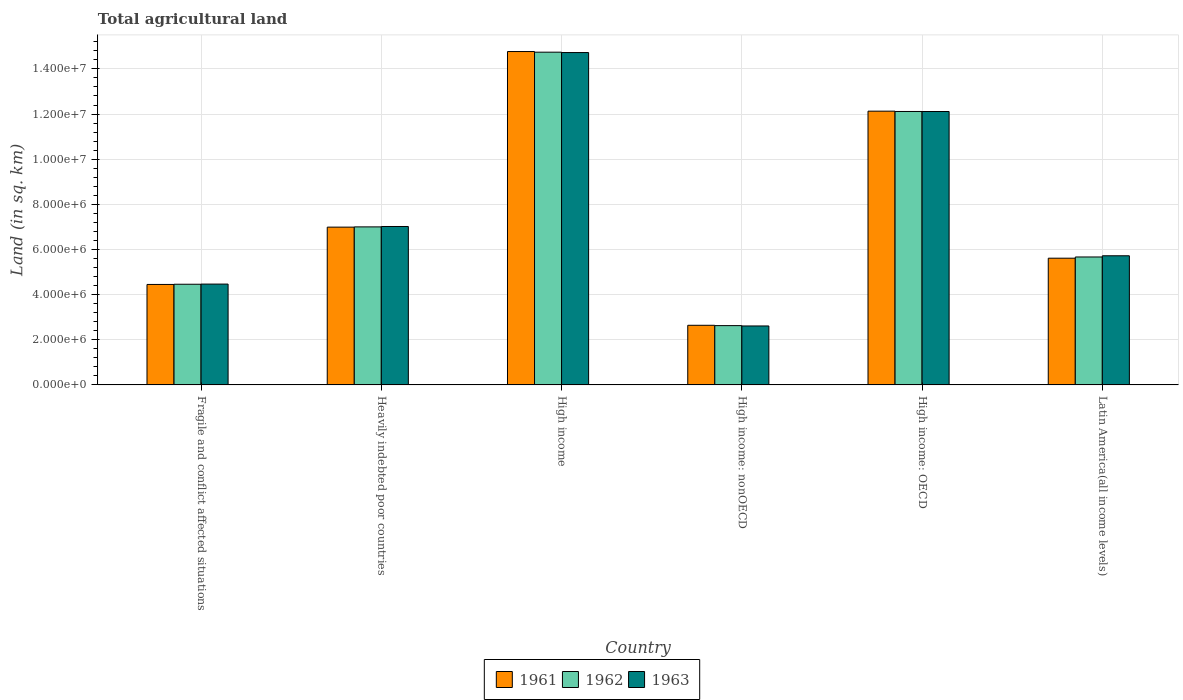How many different coloured bars are there?
Give a very brief answer. 3. Are the number of bars on each tick of the X-axis equal?
Your answer should be compact. Yes. How many bars are there on the 1st tick from the right?
Provide a succinct answer. 3. What is the label of the 6th group of bars from the left?
Provide a short and direct response. Latin America(all income levels). What is the total agricultural land in 1961 in High income?
Make the answer very short. 1.48e+07. Across all countries, what is the maximum total agricultural land in 1962?
Provide a short and direct response. 1.47e+07. Across all countries, what is the minimum total agricultural land in 1962?
Give a very brief answer. 2.63e+06. In which country was the total agricultural land in 1963 minimum?
Offer a very short reply. High income: nonOECD. What is the total total agricultural land in 1962 in the graph?
Your response must be concise. 4.66e+07. What is the difference between the total agricultural land in 1962 in Fragile and conflict affected situations and that in High income: OECD?
Offer a terse response. -7.65e+06. What is the difference between the total agricultural land in 1963 in Latin America(all income levels) and the total agricultural land in 1961 in High income: nonOECD?
Offer a terse response. 3.08e+06. What is the average total agricultural land in 1962 per country?
Offer a very short reply. 7.77e+06. What is the difference between the total agricultural land of/in 1961 and total agricultural land of/in 1963 in High income?
Give a very brief answer. 4.49e+04. In how many countries, is the total agricultural land in 1961 greater than 7200000 sq.km?
Provide a short and direct response. 2. What is the ratio of the total agricultural land in 1963 in Fragile and conflict affected situations to that in High income: nonOECD?
Your answer should be very brief. 1.71. Is the difference between the total agricultural land in 1961 in High income and Latin America(all income levels) greater than the difference between the total agricultural land in 1963 in High income and Latin America(all income levels)?
Provide a short and direct response. Yes. What is the difference between the highest and the second highest total agricultural land in 1963?
Offer a very short reply. -7.71e+06. What is the difference between the highest and the lowest total agricultural land in 1962?
Provide a succinct answer. 1.21e+07. In how many countries, is the total agricultural land in 1963 greater than the average total agricultural land in 1963 taken over all countries?
Provide a succinct answer. 2. What does the 2nd bar from the left in High income: nonOECD represents?
Your answer should be compact. 1962. What does the 3rd bar from the right in High income represents?
Keep it short and to the point. 1961. Is it the case that in every country, the sum of the total agricultural land in 1962 and total agricultural land in 1963 is greater than the total agricultural land in 1961?
Ensure brevity in your answer.  Yes. How many bars are there?
Offer a terse response. 18. Are the values on the major ticks of Y-axis written in scientific E-notation?
Offer a terse response. Yes. Does the graph contain any zero values?
Ensure brevity in your answer.  No. Does the graph contain grids?
Make the answer very short. Yes. What is the title of the graph?
Provide a succinct answer. Total agricultural land. Does "1990" appear as one of the legend labels in the graph?
Provide a short and direct response. No. What is the label or title of the Y-axis?
Offer a very short reply. Land (in sq. km). What is the Land (in sq. km) of 1961 in Fragile and conflict affected situations?
Your answer should be compact. 4.45e+06. What is the Land (in sq. km) of 1962 in Fragile and conflict affected situations?
Your answer should be compact. 4.46e+06. What is the Land (in sq. km) in 1963 in Fragile and conflict affected situations?
Keep it short and to the point. 4.47e+06. What is the Land (in sq. km) in 1961 in Heavily indebted poor countries?
Give a very brief answer. 6.99e+06. What is the Land (in sq. km) in 1962 in Heavily indebted poor countries?
Your response must be concise. 7.00e+06. What is the Land (in sq. km) in 1963 in Heavily indebted poor countries?
Offer a terse response. 7.02e+06. What is the Land (in sq. km) of 1961 in High income?
Your answer should be very brief. 1.48e+07. What is the Land (in sq. km) of 1962 in High income?
Your answer should be compact. 1.47e+07. What is the Land (in sq. km) in 1963 in High income?
Your response must be concise. 1.47e+07. What is the Land (in sq. km) of 1961 in High income: nonOECD?
Keep it short and to the point. 2.64e+06. What is the Land (in sq. km) of 1962 in High income: nonOECD?
Offer a very short reply. 2.63e+06. What is the Land (in sq. km) of 1963 in High income: nonOECD?
Provide a short and direct response. 2.61e+06. What is the Land (in sq. km) in 1961 in High income: OECD?
Keep it short and to the point. 1.21e+07. What is the Land (in sq. km) of 1962 in High income: OECD?
Offer a terse response. 1.21e+07. What is the Land (in sq. km) in 1963 in High income: OECD?
Keep it short and to the point. 1.21e+07. What is the Land (in sq. km) of 1961 in Latin America(all income levels)?
Keep it short and to the point. 5.61e+06. What is the Land (in sq. km) in 1962 in Latin America(all income levels)?
Give a very brief answer. 5.67e+06. What is the Land (in sq. km) of 1963 in Latin America(all income levels)?
Provide a short and direct response. 5.72e+06. Across all countries, what is the maximum Land (in sq. km) of 1961?
Provide a short and direct response. 1.48e+07. Across all countries, what is the maximum Land (in sq. km) of 1962?
Your response must be concise. 1.47e+07. Across all countries, what is the maximum Land (in sq. km) of 1963?
Your response must be concise. 1.47e+07. Across all countries, what is the minimum Land (in sq. km) of 1961?
Offer a terse response. 2.64e+06. Across all countries, what is the minimum Land (in sq. km) in 1962?
Offer a very short reply. 2.63e+06. Across all countries, what is the minimum Land (in sq. km) in 1963?
Offer a terse response. 2.61e+06. What is the total Land (in sq. km) in 1961 in the graph?
Offer a terse response. 4.66e+07. What is the total Land (in sq. km) of 1962 in the graph?
Ensure brevity in your answer.  4.66e+07. What is the total Land (in sq. km) of 1963 in the graph?
Keep it short and to the point. 4.67e+07. What is the difference between the Land (in sq. km) in 1961 in Fragile and conflict affected situations and that in Heavily indebted poor countries?
Provide a short and direct response. -2.54e+06. What is the difference between the Land (in sq. km) in 1962 in Fragile and conflict affected situations and that in Heavily indebted poor countries?
Provide a succinct answer. -2.54e+06. What is the difference between the Land (in sq. km) in 1963 in Fragile and conflict affected situations and that in Heavily indebted poor countries?
Provide a short and direct response. -2.55e+06. What is the difference between the Land (in sq. km) of 1961 in Fragile and conflict affected situations and that in High income?
Ensure brevity in your answer.  -1.03e+07. What is the difference between the Land (in sq. km) in 1962 in Fragile and conflict affected situations and that in High income?
Ensure brevity in your answer.  -1.03e+07. What is the difference between the Land (in sq. km) of 1963 in Fragile and conflict affected situations and that in High income?
Your answer should be compact. -1.03e+07. What is the difference between the Land (in sq. km) in 1961 in Fragile and conflict affected situations and that in High income: nonOECD?
Your response must be concise. 1.81e+06. What is the difference between the Land (in sq. km) in 1962 in Fragile and conflict affected situations and that in High income: nonOECD?
Your response must be concise. 1.83e+06. What is the difference between the Land (in sq. km) in 1963 in Fragile and conflict affected situations and that in High income: nonOECD?
Provide a succinct answer. 1.86e+06. What is the difference between the Land (in sq. km) of 1961 in Fragile and conflict affected situations and that in High income: OECD?
Make the answer very short. -7.68e+06. What is the difference between the Land (in sq. km) in 1962 in Fragile and conflict affected situations and that in High income: OECD?
Give a very brief answer. -7.65e+06. What is the difference between the Land (in sq. km) of 1963 in Fragile and conflict affected situations and that in High income: OECD?
Provide a succinct answer. -7.65e+06. What is the difference between the Land (in sq. km) of 1961 in Fragile and conflict affected situations and that in Latin America(all income levels)?
Provide a short and direct response. -1.16e+06. What is the difference between the Land (in sq. km) of 1962 in Fragile and conflict affected situations and that in Latin America(all income levels)?
Provide a succinct answer. -1.21e+06. What is the difference between the Land (in sq. km) in 1963 in Fragile and conflict affected situations and that in Latin America(all income levels)?
Ensure brevity in your answer.  -1.25e+06. What is the difference between the Land (in sq. km) in 1961 in Heavily indebted poor countries and that in High income?
Offer a terse response. -7.78e+06. What is the difference between the Land (in sq. km) of 1962 in Heavily indebted poor countries and that in High income?
Your answer should be compact. -7.74e+06. What is the difference between the Land (in sq. km) of 1963 in Heavily indebted poor countries and that in High income?
Provide a short and direct response. -7.71e+06. What is the difference between the Land (in sq. km) of 1961 in Heavily indebted poor countries and that in High income: nonOECD?
Offer a very short reply. 4.35e+06. What is the difference between the Land (in sq. km) of 1962 in Heavily indebted poor countries and that in High income: nonOECD?
Ensure brevity in your answer.  4.37e+06. What is the difference between the Land (in sq. km) in 1963 in Heavily indebted poor countries and that in High income: nonOECD?
Make the answer very short. 4.41e+06. What is the difference between the Land (in sq. km) of 1961 in Heavily indebted poor countries and that in High income: OECD?
Provide a succinct answer. -5.14e+06. What is the difference between the Land (in sq. km) in 1962 in Heavily indebted poor countries and that in High income: OECD?
Make the answer very short. -5.11e+06. What is the difference between the Land (in sq. km) in 1963 in Heavily indebted poor countries and that in High income: OECD?
Offer a very short reply. -5.09e+06. What is the difference between the Land (in sq. km) of 1961 in Heavily indebted poor countries and that in Latin America(all income levels)?
Make the answer very short. 1.38e+06. What is the difference between the Land (in sq. km) in 1962 in Heavily indebted poor countries and that in Latin America(all income levels)?
Make the answer very short. 1.33e+06. What is the difference between the Land (in sq. km) in 1963 in Heavily indebted poor countries and that in Latin America(all income levels)?
Offer a very short reply. 1.30e+06. What is the difference between the Land (in sq. km) of 1961 in High income and that in High income: nonOECD?
Keep it short and to the point. 1.21e+07. What is the difference between the Land (in sq. km) of 1962 in High income and that in High income: nonOECD?
Offer a terse response. 1.21e+07. What is the difference between the Land (in sq. km) in 1963 in High income and that in High income: nonOECD?
Offer a terse response. 1.21e+07. What is the difference between the Land (in sq. km) of 1961 in High income and that in High income: OECD?
Keep it short and to the point. 2.64e+06. What is the difference between the Land (in sq. km) in 1962 in High income and that in High income: OECD?
Your response must be concise. 2.63e+06. What is the difference between the Land (in sq. km) of 1963 in High income and that in High income: OECD?
Make the answer very short. 2.61e+06. What is the difference between the Land (in sq. km) in 1961 in High income and that in Latin America(all income levels)?
Your answer should be compact. 9.15e+06. What is the difference between the Land (in sq. km) of 1962 in High income and that in Latin America(all income levels)?
Make the answer very short. 9.07e+06. What is the difference between the Land (in sq. km) of 1963 in High income and that in Latin America(all income levels)?
Keep it short and to the point. 9.00e+06. What is the difference between the Land (in sq. km) of 1961 in High income: nonOECD and that in High income: OECD?
Provide a succinct answer. -9.49e+06. What is the difference between the Land (in sq. km) in 1962 in High income: nonOECD and that in High income: OECD?
Offer a very short reply. -9.49e+06. What is the difference between the Land (in sq. km) in 1963 in High income: nonOECD and that in High income: OECD?
Give a very brief answer. -9.50e+06. What is the difference between the Land (in sq. km) of 1961 in High income: nonOECD and that in Latin America(all income levels)?
Make the answer very short. -2.97e+06. What is the difference between the Land (in sq. km) of 1962 in High income: nonOECD and that in Latin America(all income levels)?
Give a very brief answer. -3.04e+06. What is the difference between the Land (in sq. km) in 1963 in High income: nonOECD and that in Latin America(all income levels)?
Keep it short and to the point. -3.11e+06. What is the difference between the Land (in sq. km) in 1961 in High income: OECD and that in Latin America(all income levels)?
Give a very brief answer. 6.51e+06. What is the difference between the Land (in sq. km) of 1962 in High income: OECD and that in Latin America(all income levels)?
Ensure brevity in your answer.  6.44e+06. What is the difference between the Land (in sq. km) in 1963 in High income: OECD and that in Latin America(all income levels)?
Make the answer very short. 6.39e+06. What is the difference between the Land (in sq. km) of 1961 in Fragile and conflict affected situations and the Land (in sq. km) of 1962 in Heavily indebted poor countries?
Give a very brief answer. -2.55e+06. What is the difference between the Land (in sq. km) in 1961 in Fragile and conflict affected situations and the Land (in sq. km) in 1963 in Heavily indebted poor countries?
Your answer should be compact. -2.57e+06. What is the difference between the Land (in sq. km) in 1962 in Fragile and conflict affected situations and the Land (in sq. km) in 1963 in Heavily indebted poor countries?
Your answer should be very brief. -2.56e+06. What is the difference between the Land (in sq. km) in 1961 in Fragile and conflict affected situations and the Land (in sq. km) in 1962 in High income?
Your answer should be very brief. -1.03e+07. What is the difference between the Land (in sq. km) of 1961 in Fragile and conflict affected situations and the Land (in sq. km) of 1963 in High income?
Your answer should be very brief. -1.03e+07. What is the difference between the Land (in sq. km) in 1962 in Fragile and conflict affected situations and the Land (in sq. km) in 1963 in High income?
Your answer should be compact. -1.03e+07. What is the difference between the Land (in sq. km) of 1961 in Fragile and conflict affected situations and the Land (in sq. km) of 1962 in High income: nonOECD?
Give a very brief answer. 1.82e+06. What is the difference between the Land (in sq. km) of 1961 in Fragile and conflict affected situations and the Land (in sq. km) of 1963 in High income: nonOECD?
Your answer should be very brief. 1.84e+06. What is the difference between the Land (in sq. km) in 1962 in Fragile and conflict affected situations and the Land (in sq. km) in 1963 in High income: nonOECD?
Give a very brief answer. 1.85e+06. What is the difference between the Land (in sq. km) of 1961 in Fragile and conflict affected situations and the Land (in sq. km) of 1962 in High income: OECD?
Your response must be concise. -7.66e+06. What is the difference between the Land (in sq. km) in 1961 in Fragile and conflict affected situations and the Land (in sq. km) in 1963 in High income: OECD?
Give a very brief answer. -7.66e+06. What is the difference between the Land (in sq. km) in 1962 in Fragile and conflict affected situations and the Land (in sq. km) in 1963 in High income: OECD?
Make the answer very short. -7.65e+06. What is the difference between the Land (in sq. km) in 1961 in Fragile and conflict affected situations and the Land (in sq. km) in 1962 in Latin America(all income levels)?
Provide a short and direct response. -1.22e+06. What is the difference between the Land (in sq. km) in 1961 in Fragile and conflict affected situations and the Land (in sq. km) in 1963 in Latin America(all income levels)?
Make the answer very short. -1.27e+06. What is the difference between the Land (in sq. km) in 1962 in Fragile and conflict affected situations and the Land (in sq. km) in 1963 in Latin America(all income levels)?
Give a very brief answer. -1.26e+06. What is the difference between the Land (in sq. km) of 1961 in Heavily indebted poor countries and the Land (in sq. km) of 1962 in High income?
Ensure brevity in your answer.  -7.75e+06. What is the difference between the Land (in sq. km) in 1961 in Heavily indebted poor countries and the Land (in sq. km) in 1963 in High income?
Offer a very short reply. -7.73e+06. What is the difference between the Land (in sq. km) of 1962 in Heavily indebted poor countries and the Land (in sq. km) of 1963 in High income?
Make the answer very short. -7.72e+06. What is the difference between the Land (in sq. km) in 1961 in Heavily indebted poor countries and the Land (in sq. km) in 1962 in High income: nonOECD?
Give a very brief answer. 4.36e+06. What is the difference between the Land (in sq. km) in 1961 in Heavily indebted poor countries and the Land (in sq. km) in 1963 in High income: nonOECD?
Your answer should be very brief. 4.38e+06. What is the difference between the Land (in sq. km) in 1962 in Heavily indebted poor countries and the Land (in sq. km) in 1963 in High income: nonOECD?
Ensure brevity in your answer.  4.39e+06. What is the difference between the Land (in sq. km) of 1961 in Heavily indebted poor countries and the Land (in sq. km) of 1962 in High income: OECD?
Give a very brief answer. -5.12e+06. What is the difference between the Land (in sq. km) in 1961 in Heavily indebted poor countries and the Land (in sq. km) in 1963 in High income: OECD?
Provide a short and direct response. -5.12e+06. What is the difference between the Land (in sq. km) of 1962 in Heavily indebted poor countries and the Land (in sq. km) of 1963 in High income: OECD?
Offer a terse response. -5.11e+06. What is the difference between the Land (in sq. km) of 1961 in Heavily indebted poor countries and the Land (in sq. km) of 1962 in Latin America(all income levels)?
Your response must be concise. 1.32e+06. What is the difference between the Land (in sq. km) in 1961 in Heavily indebted poor countries and the Land (in sq. km) in 1963 in Latin America(all income levels)?
Your response must be concise. 1.27e+06. What is the difference between the Land (in sq. km) in 1962 in Heavily indebted poor countries and the Land (in sq. km) in 1963 in Latin America(all income levels)?
Offer a very short reply. 1.28e+06. What is the difference between the Land (in sq. km) of 1961 in High income and the Land (in sq. km) of 1962 in High income: nonOECD?
Offer a terse response. 1.21e+07. What is the difference between the Land (in sq. km) in 1961 in High income and the Land (in sq. km) in 1963 in High income: nonOECD?
Your response must be concise. 1.22e+07. What is the difference between the Land (in sq. km) of 1962 in High income and the Land (in sq. km) of 1963 in High income: nonOECD?
Ensure brevity in your answer.  1.21e+07. What is the difference between the Land (in sq. km) in 1961 in High income and the Land (in sq. km) in 1962 in High income: OECD?
Make the answer very short. 2.66e+06. What is the difference between the Land (in sq. km) in 1961 in High income and the Land (in sq. km) in 1963 in High income: OECD?
Give a very brief answer. 2.66e+06. What is the difference between the Land (in sq. km) of 1962 in High income and the Land (in sq. km) of 1963 in High income: OECD?
Your response must be concise. 2.63e+06. What is the difference between the Land (in sq. km) in 1961 in High income and the Land (in sq. km) in 1962 in Latin America(all income levels)?
Ensure brevity in your answer.  9.10e+06. What is the difference between the Land (in sq. km) in 1961 in High income and the Land (in sq. km) in 1963 in Latin America(all income levels)?
Provide a short and direct response. 9.05e+06. What is the difference between the Land (in sq. km) in 1962 in High income and the Land (in sq. km) in 1963 in Latin America(all income levels)?
Your answer should be very brief. 9.02e+06. What is the difference between the Land (in sq. km) of 1961 in High income: nonOECD and the Land (in sq. km) of 1962 in High income: OECD?
Your response must be concise. -9.47e+06. What is the difference between the Land (in sq. km) in 1961 in High income: nonOECD and the Land (in sq. km) in 1963 in High income: OECD?
Ensure brevity in your answer.  -9.47e+06. What is the difference between the Land (in sq. km) of 1962 in High income: nonOECD and the Land (in sq. km) of 1963 in High income: OECD?
Give a very brief answer. -9.48e+06. What is the difference between the Land (in sq. km) in 1961 in High income: nonOECD and the Land (in sq. km) in 1962 in Latin America(all income levels)?
Provide a succinct answer. -3.03e+06. What is the difference between the Land (in sq. km) of 1961 in High income: nonOECD and the Land (in sq. km) of 1963 in Latin America(all income levels)?
Your answer should be compact. -3.08e+06. What is the difference between the Land (in sq. km) in 1962 in High income: nonOECD and the Land (in sq. km) in 1963 in Latin America(all income levels)?
Your answer should be compact. -3.09e+06. What is the difference between the Land (in sq. km) in 1961 in High income: OECD and the Land (in sq. km) in 1962 in Latin America(all income levels)?
Provide a short and direct response. 6.46e+06. What is the difference between the Land (in sq. km) of 1961 in High income: OECD and the Land (in sq. km) of 1963 in Latin America(all income levels)?
Provide a succinct answer. 6.41e+06. What is the difference between the Land (in sq. km) of 1962 in High income: OECD and the Land (in sq. km) of 1963 in Latin America(all income levels)?
Offer a terse response. 6.39e+06. What is the average Land (in sq. km) of 1961 per country?
Keep it short and to the point. 7.76e+06. What is the average Land (in sq. km) of 1962 per country?
Your answer should be very brief. 7.77e+06. What is the average Land (in sq. km) in 1963 per country?
Make the answer very short. 7.78e+06. What is the difference between the Land (in sq. km) of 1961 and Land (in sq. km) of 1962 in Fragile and conflict affected situations?
Your answer should be very brief. -8900. What is the difference between the Land (in sq. km) in 1961 and Land (in sq. km) in 1963 in Fragile and conflict affected situations?
Ensure brevity in your answer.  -1.61e+04. What is the difference between the Land (in sq. km) of 1962 and Land (in sq. km) of 1963 in Fragile and conflict affected situations?
Your response must be concise. -7160. What is the difference between the Land (in sq. km) of 1961 and Land (in sq. km) of 1962 in Heavily indebted poor countries?
Offer a terse response. -1.13e+04. What is the difference between the Land (in sq. km) of 1961 and Land (in sq. km) of 1963 in Heavily indebted poor countries?
Keep it short and to the point. -2.84e+04. What is the difference between the Land (in sq. km) in 1962 and Land (in sq. km) in 1963 in Heavily indebted poor countries?
Your response must be concise. -1.71e+04. What is the difference between the Land (in sq. km) of 1961 and Land (in sq. km) of 1962 in High income?
Your answer should be very brief. 2.83e+04. What is the difference between the Land (in sq. km) in 1961 and Land (in sq. km) in 1963 in High income?
Give a very brief answer. 4.49e+04. What is the difference between the Land (in sq. km) in 1962 and Land (in sq. km) in 1963 in High income?
Give a very brief answer. 1.66e+04. What is the difference between the Land (in sq. km) in 1961 and Land (in sq. km) in 1962 in High income: nonOECD?
Ensure brevity in your answer.  1.42e+04. What is the difference between the Land (in sq. km) of 1961 and Land (in sq. km) of 1963 in High income: nonOECD?
Your answer should be compact. 2.98e+04. What is the difference between the Land (in sq. km) of 1962 and Land (in sq. km) of 1963 in High income: nonOECD?
Make the answer very short. 1.56e+04. What is the difference between the Land (in sq. km) in 1961 and Land (in sq. km) in 1962 in High income: OECD?
Ensure brevity in your answer.  1.41e+04. What is the difference between the Land (in sq. km) in 1961 and Land (in sq. km) in 1963 in High income: OECD?
Offer a terse response. 1.52e+04. What is the difference between the Land (in sq. km) in 1962 and Land (in sq. km) in 1963 in High income: OECD?
Make the answer very short. 1028. What is the difference between the Land (in sq. km) in 1961 and Land (in sq. km) in 1962 in Latin America(all income levels)?
Offer a terse response. -5.45e+04. What is the difference between the Land (in sq. km) in 1961 and Land (in sq. km) in 1963 in Latin America(all income levels)?
Ensure brevity in your answer.  -1.07e+05. What is the difference between the Land (in sq. km) in 1962 and Land (in sq. km) in 1963 in Latin America(all income levels)?
Your answer should be compact. -5.29e+04. What is the ratio of the Land (in sq. km) of 1961 in Fragile and conflict affected situations to that in Heavily indebted poor countries?
Keep it short and to the point. 0.64. What is the ratio of the Land (in sq. km) in 1962 in Fragile and conflict affected situations to that in Heavily indebted poor countries?
Your response must be concise. 0.64. What is the ratio of the Land (in sq. km) of 1963 in Fragile and conflict affected situations to that in Heavily indebted poor countries?
Your response must be concise. 0.64. What is the ratio of the Land (in sq. km) in 1961 in Fragile and conflict affected situations to that in High income?
Your response must be concise. 0.3. What is the ratio of the Land (in sq. km) of 1962 in Fragile and conflict affected situations to that in High income?
Offer a very short reply. 0.3. What is the ratio of the Land (in sq. km) in 1963 in Fragile and conflict affected situations to that in High income?
Your response must be concise. 0.3. What is the ratio of the Land (in sq. km) of 1961 in Fragile and conflict affected situations to that in High income: nonOECD?
Make the answer very short. 1.69. What is the ratio of the Land (in sq. km) in 1962 in Fragile and conflict affected situations to that in High income: nonOECD?
Provide a short and direct response. 1.7. What is the ratio of the Land (in sq. km) in 1963 in Fragile and conflict affected situations to that in High income: nonOECD?
Your answer should be very brief. 1.71. What is the ratio of the Land (in sq. km) in 1961 in Fragile and conflict affected situations to that in High income: OECD?
Make the answer very short. 0.37. What is the ratio of the Land (in sq. km) in 1962 in Fragile and conflict affected situations to that in High income: OECD?
Provide a short and direct response. 0.37. What is the ratio of the Land (in sq. km) in 1963 in Fragile and conflict affected situations to that in High income: OECD?
Offer a terse response. 0.37. What is the ratio of the Land (in sq. km) of 1961 in Fragile and conflict affected situations to that in Latin America(all income levels)?
Give a very brief answer. 0.79. What is the ratio of the Land (in sq. km) in 1962 in Fragile and conflict affected situations to that in Latin America(all income levels)?
Keep it short and to the point. 0.79. What is the ratio of the Land (in sq. km) of 1963 in Fragile and conflict affected situations to that in Latin America(all income levels)?
Give a very brief answer. 0.78. What is the ratio of the Land (in sq. km) of 1961 in Heavily indebted poor countries to that in High income?
Ensure brevity in your answer.  0.47. What is the ratio of the Land (in sq. km) in 1962 in Heavily indebted poor countries to that in High income?
Offer a very short reply. 0.47. What is the ratio of the Land (in sq. km) of 1963 in Heavily indebted poor countries to that in High income?
Your answer should be very brief. 0.48. What is the ratio of the Land (in sq. km) in 1961 in Heavily indebted poor countries to that in High income: nonOECD?
Provide a short and direct response. 2.65. What is the ratio of the Land (in sq. km) of 1962 in Heavily indebted poor countries to that in High income: nonOECD?
Offer a very short reply. 2.66. What is the ratio of the Land (in sq. km) of 1963 in Heavily indebted poor countries to that in High income: nonOECD?
Provide a succinct answer. 2.69. What is the ratio of the Land (in sq. km) in 1961 in Heavily indebted poor countries to that in High income: OECD?
Your answer should be very brief. 0.58. What is the ratio of the Land (in sq. km) of 1962 in Heavily indebted poor countries to that in High income: OECD?
Your answer should be very brief. 0.58. What is the ratio of the Land (in sq. km) in 1963 in Heavily indebted poor countries to that in High income: OECD?
Provide a short and direct response. 0.58. What is the ratio of the Land (in sq. km) of 1961 in Heavily indebted poor countries to that in Latin America(all income levels)?
Offer a very short reply. 1.25. What is the ratio of the Land (in sq. km) in 1962 in Heavily indebted poor countries to that in Latin America(all income levels)?
Your answer should be very brief. 1.24. What is the ratio of the Land (in sq. km) in 1963 in Heavily indebted poor countries to that in Latin America(all income levels)?
Ensure brevity in your answer.  1.23. What is the ratio of the Land (in sq. km) in 1961 in High income to that in High income: nonOECD?
Give a very brief answer. 5.59. What is the ratio of the Land (in sq. km) in 1962 in High income to that in High income: nonOECD?
Offer a terse response. 5.61. What is the ratio of the Land (in sq. km) in 1963 in High income to that in High income: nonOECD?
Provide a short and direct response. 5.64. What is the ratio of the Land (in sq. km) in 1961 in High income to that in High income: OECD?
Give a very brief answer. 1.22. What is the ratio of the Land (in sq. km) in 1962 in High income to that in High income: OECD?
Offer a terse response. 1.22. What is the ratio of the Land (in sq. km) in 1963 in High income to that in High income: OECD?
Keep it short and to the point. 1.22. What is the ratio of the Land (in sq. km) in 1961 in High income to that in Latin America(all income levels)?
Offer a terse response. 2.63. What is the ratio of the Land (in sq. km) of 1962 in High income to that in Latin America(all income levels)?
Offer a terse response. 2.6. What is the ratio of the Land (in sq. km) of 1963 in High income to that in Latin America(all income levels)?
Keep it short and to the point. 2.57. What is the ratio of the Land (in sq. km) of 1961 in High income: nonOECD to that in High income: OECD?
Keep it short and to the point. 0.22. What is the ratio of the Land (in sq. km) of 1962 in High income: nonOECD to that in High income: OECD?
Provide a short and direct response. 0.22. What is the ratio of the Land (in sq. km) of 1963 in High income: nonOECD to that in High income: OECD?
Give a very brief answer. 0.22. What is the ratio of the Land (in sq. km) of 1961 in High income: nonOECD to that in Latin America(all income levels)?
Ensure brevity in your answer.  0.47. What is the ratio of the Land (in sq. km) of 1962 in High income: nonOECD to that in Latin America(all income levels)?
Give a very brief answer. 0.46. What is the ratio of the Land (in sq. km) of 1963 in High income: nonOECD to that in Latin America(all income levels)?
Provide a short and direct response. 0.46. What is the ratio of the Land (in sq. km) in 1961 in High income: OECD to that in Latin America(all income levels)?
Ensure brevity in your answer.  2.16. What is the ratio of the Land (in sq. km) of 1962 in High income: OECD to that in Latin America(all income levels)?
Provide a short and direct response. 2.14. What is the ratio of the Land (in sq. km) of 1963 in High income: OECD to that in Latin America(all income levels)?
Provide a succinct answer. 2.12. What is the difference between the highest and the second highest Land (in sq. km) of 1961?
Your answer should be very brief. 2.64e+06. What is the difference between the highest and the second highest Land (in sq. km) of 1962?
Your response must be concise. 2.63e+06. What is the difference between the highest and the second highest Land (in sq. km) of 1963?
Keep it short and to the point. 2.61e+06. What is the difference between the highest and the lowest Land (in sq. km) of 1961?
Your answer should be very brief. 1.21e+07. What is the difference between the highest and the lowest Land (in sq. km) in 1962?
Provide a succinct answer. 1.21e+07. What is the difference between the highest and the lowest Land (in sq. km) of 1963?
Offer a terse response. 1.21e+07. 